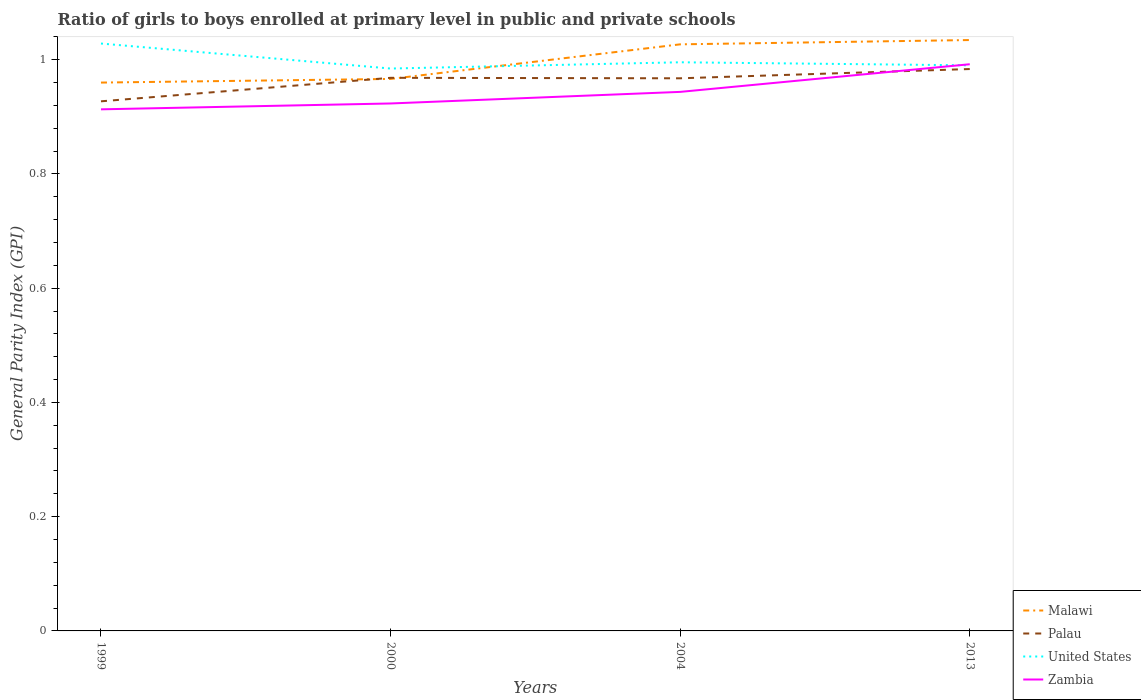Is the number of lines equal to the number of legend labels?
Your answer should be very brief. Yes. Across all years, what is the maximum general parity index in Malawi?
Offer a terse response. 0.96. What is the total general parity index in Zambia in the graph?
Make the answer very short. -0.03. What is the difference between the highest and the second highest general parity index in Palau?
Your answer should be compact. 0.06. Is the general parity index in United States strictly greater than the general parity index in Palau over the years?
Make the answer very short. No. How many lines are there?
Offer a terse response. 4. How many years are there in the graph?
Ensure brevity in your answer.  4. What is the difference between two consecutive major ticks on the Y-axis?
Keep it short and to the point. 0.2. Are the values on the major ticks of Y-axis written in scientific E-notation?
Ensure brevity in your answer.  No. Does the graph contain any zero values?
Provide a succinct answer. No. Does the graph contain grids?
Keep it short and to the point. No. What is the title of the graph?
Keep it short and to the point. Ratio of girls to boys enrolled at primary level in public and private schools. Does "United Arab Emirates" appear as one of the legend labels in the graph?
Your answer should be very brief. No. What is the label or title of the X-axis?
Offer a terse response. Years. What is the label or title of the Y-axis?
Your response must be concise. General Parity Index (GPI). What is the General Parity Index (GPI) of Malawi in 1999?
Offer a very short reply. 0.96. What is the General Parity Index (GPI) in Palau in 1999?
Keep it short and to the point. 0.93. What is the General Parity Index (GPI) of United States in 1999?
Make the answer very short. 1.03. What is the General Parity Index (GPI) of Zambia in 1999?
Offer a terse response. 0.91. What is the General Parity Index (GPI) in Malawi in 2000?
Ensure brevity in your answer.  0.97. What is the General Parity Index (GPI) in Palau in 2000?
Give a very brief answer. 0.97. What is the General Parity Index (GPI) in United States in 2000?
Your answer should be compact. 0.98. What is the General Parity Index (GPI) of Zambia in 2000?
Ensure brevity in your answer.  0.92. What is the General Parity Index (GPI) of Malawi in 2004?
Your answer should be compact. 1.03. What is the General Parity Index (GPI) of Palau in 2004?
Make the answer very short. 0.97. What is the General Parity Index (GPI) of United States in 2004?
Offer a terse response. 1. What is the General Parity Index (GPI) in Zambia in 2004?
Make the answer very short. 0.94. What is the General Parity Index (GPI) in Malawi in 2013?
Your answer should be compact. 1.03. What is the General Parity Index (GPI) in Palau in 2013?
Offer a terse response. 0.98. What is the General Parity Index (GPI) in United States in 2013?
Make the answer very short. 0.99. What is the General Parity Index (GPI) in Zambia in 2013?
Your response must be concise. 0.99. Across all years, what is the maximum General Parity Index (GPI) of Malawi?
Provide a succinct answer. 1.03. Across all years, what is the maximum General Parity Index (GPI) in Palau?
Give a very brief answer. 0.98. Across all years, what is the maximum General Parity Index (GPI) in United States?
Give a very brief answer. 1.03. Across all years, what is the maximum General Parity Index (GPI) of Zambia?
Make the answer very short. 0.99. Across all years, what is the minimum General Parity Index (GPI) of Malawi?
Your answer should be compact. 0.96. Across all years, what is the minimum General Parity Index (GPI) in Palau?
Provide a succinct answer. 0.93. Across all years, what is the minimum General Parity Index (GPI) of United States?
Your answer should be very brief. 0.98. Across all years, what is the minimum General Parity Index (GPI) of Zambia?
Give a very brief answer. 0.91. What is the total General Parity Index (GPI) of Malawi in the graph?
Your answer should be very brief. 3.99. What is the total General Parity Index (GPI) of Palau in the graph?
Your answer should be very brief. 3.85. What is the total General Parity Index (GPI) of United States in the graph?
Provide a succinct answer. 4. What is the total General Parity Index (GPI) of Zambia in the graph?
Ensure brevity in your answer.  3.77. What is the difference between the General Parity Index (GPI) of Malawi in 1999 and that in 2000?
Offer a very short reply. -0.01. What is the difference between the General Parity Index (GPI) of Palau in 1999 and that in 2000?
Make the answer very short. -0.04. What is the difference between the General Parity Index (GPI) of United States in 1999 and that in 2000?
Provide a short and direct response. 0.04. What is the difference between the General Parity Index (GPI) in Zambia in 1999 and that in 2000?
Provide a short and direct response. -0.01. What is the difference between the General Parity Index (GPI) in Malawi in 1999 and that in 2004?
Offer a very short reply. -0.07. What is the difference between the General Parity Index (GPI) of Palau in 1999 and that in 2004?
Offer a very short reply. -0.04. What is the difference between the General Parity Index (GPI) of United States in 1999 and that in 2004?
Provide a short and direct response. 0.03. What is the difference between the General Parity Index (GPI) in Zambia in 1999 and that in 2004?
Keep it short and to the point. -0.03. What is the difference between the General Parity Index (GPI) in Malawi in 1999 and that in 2013?
Keep it short and to the point. -0.07. What is the difference between the General Parity Index (GPI) of Palau in 1999 and that in 2013?
Provide a short and direct response. -0.06. What is the difference between the General Parity Index (GPI) in United States in 1999 and that in 2013?
Ensure brevity in your answer.  0.04. What is the difference between the General Parity Index (GPI) of Zambia in 1999 and that in 2013?
Offer a very short reply. -0.08. What is the difference between the General Parity Index (GPI) of Malawi in 2000 and that in 2004?
Your answer should be very brief. -0.06. What is the difference between the General Parity Index (GPI) of Palau in 2000 and that in 2004?
Provide a short and direct response. 0. What is the difference between the General Parity Index (GPI) of United States in 2000 and that in 2004?
Ensure brevity in your answer.  -0.01. What is the difference between the General Parity Index (GPI) of Zambia in 2000 and that in 2004?
Ensure brevity in your answer.  -0.02. What is the difference between the General Parity Index (GPI) of Malawi in 2000 and that in 2013?
Your response must be concise. -0.07. What is the difference between the General Parity Index (GPI) of Palau in 2000 and that in 2013?
Your answer should be compact. -0.02. What is the difference between the General Parity Index (GPI) in United States in 2000 and that in 2013?
Give a very brief answer. -0.01. What is the difference between the General Parity Index (GPI) in Zambia in 2000 and that in 2013?
Your answer should be very brief. -0.07. What is the difference between the General Parity Index (GPI) of Malawi in 2004 and that in 2013?
Make the answer very short. -0.01. What is the difference between the General Parity Index (GPI) in Palau in 2004 and that in 2013?
Your answer should be compact. -0.02. What is the difference between the General Parity Index (GPI) of United States in 2004 and that in 2013?
Offer a terse response. 0.01. What is the difference between the General Parity Index (GPI) of Zambia in 2004 and that in 2013?
Offer a very short reply. -0.05. What is the difference between the General Parity Index (GPI) in Malawi in 1999 and the General Parity Index (GPI) in Palau in 2000?
Provide a short and direct response. -0.01. What is the difference between the General Parity Index (GPI) of Malawi in 1999 and the General Parity Index (GPI) of United States in 2000?
Your response must be concise. -0.02. What is the difference between the General Parity Index (GPI) of Malawi in 1999 and the General Parity Index (GPI) of Zambia in 2000?
Provide a short and direct response. 0.04. What is the difference between the General Parity Index (GPI) in Palau in 1999 and the General Parity Index (GPI) in United States in 2000?
Ensure brevity in your answer.  -0.06. What is the difference between the General Parity Index (GPI) of Palau in 1999 and the General Parity Index (GPI) of Zambia in 2000?
Keep it short and to the point. 0. What is the difference between the General Parity Index (GPI) of United States in 1999 and the General Parity Index (GPI) of Zambia in 2000?
Your response must be concise. 0.1. What is the difference between the General Parity Index (GPI) of Malawi in 1999 and the General Parity Index (GPI) of Palau in 2004?
Your response must be concise. -0.01. What is the difference between the General Parity Index (GPI) of Malawi in 1999 and the General Parity Index (GPI) of United States in 2004?
Your response must be concise. -0.04. What is the difference between the General Parity Index (GPI) of Malawi in 1999 and the General Parity Index (GPI) of Zambia in 2004?
Provide a short and direct response. 0.02. What is the difference between the General Parity Index (GPI) of Palau in 1999 and the General Parity Index (GPI) of United States in 2004?
Your response must be concise. -0.07. What is the difference between the General Parity Index (GPI) in Palau in 1999 and the General Parity Index (GPI) in Zambia in 2004?
Your response must be concise. -0.02. What is the difference between the General Parity Index (GPI) of United States in 1999 and the General Parity Index (GPI) of Zambia in 2004?
Give a very brief answer. 0.08. What is the difference between the General Parity Index (GPI) in Malawi in 1999 and the General Parity Index (GPI) in Palau in 2013?
Ensure brevity in your answer.  -0.02. What is the difference between the General Parity Index (GPI) in Malawi in 1999 and the General Parity Index (GPI) in United States in 2013?
Offer a very short reply. -0.03. What is the difference between the General Parity Index (GPI) in Malawi in 1999 and the General Parity Index (GPI) in Zambia in 2013?
Your response must be concise. -0.03. What is the difference between the General Parity Index (GPI) in Palau in 1999 and the General Parity Index (GPI) in United States in 2013?
Make the answer very short. -0.06. What is the difference between the General Parity Index (GPI) of Palau in 1999 and the General Parity Index (GPI) of Zambia in 2013?
Keep it short and to the point. -0.06. What is the difference between the General Parity Index (GPI) in United States in 1999 and the General Parity Index (GPI) in Zambia in 2013?
Provide a short and direct response. 0.04. What is the difference between the General Parity Index (GPI) in Malawi in 2000 and the General Parity Index (GPI) in Palau in 2004?
Give a very brief answer. -0. What is the difference between the General Parity Index (GPI) of Malawi in 2000 and the General Parity Index (GPI) of United States in 2004?
Your answer should be compact. -0.03. What is the difference between the General Parity Index (GPI) of Malawi in 2000 and the General Parity Index (GPI) of Zambia in 2004?
Ensure brevity in your answer.  0.02. What is the difference between the General Parity Index (GPI) of Palau in 2000 and the General Parity Index (GPI) of United States in 2004?
Your answer should be very brief. -0.03. What is the difference between the General Parity Index (GPI) of Palau in 2000 and the General Parity Index (GPI) of Zambia in 2004?
Ensure brevity in your answer.  0.02. What is the difference between the General Parity Index (GPI) of United States in 2000 and the General Parity Index (GPI) of Zambia in 2004?
Make the answer very short. 0.04. What is the difference between the General Parity Index (GPI) of Malawi in 2000 and the General Parity Index (GPI) of Palau in 2013?
Offer a very short reply. -0.02. What is the difference between the General Parity Index (GPI) of Malawi in 2000 and the General Parity Index (GPI) of United States in 2013?
Offer a very short reply. -0.02. What is the difference between the General Parity Index (GPI) in Malawi in 2000 and the General Parity Index (GPI) in Zambia in 2013?
Your answer should be very brief. -0.03. What is the difference between the General Parity Index (GPI) in Palau in 2000 and the General Parity Index (GPI) in United States in 2013?
Give a very brief answer. -0.02. What is the difference between the General Parity Index (GPI) in Palau in 2000 and the General Parity Index (GPI) in Zambia in 2013?
Keep it short and to the point. -0.02. What is the difference between the General Parity Index (GPI) in United States in 2000 and the General Parity Index (GPI) in Zambia in 2013?
Keep it short and to the point. -0.01. What is the difference between the General Parity Index (GPI) in Malawi in 2004 and the General Parity Index (GPI) in Palau in 2013?
Keep it short and to the point. 0.04. What is the difference between the General Parity Index (GPI) of Malawi in 2004 and the General Parity Index (GPI) of United States in 2013?
Give a very brief answer. 0.04. What is the difference between the General Parity Index (GPI) in Malawi in 2004 and the General Parity Index (GPI) in Zambia in 2013?
Your response must be concise. 0.03. What is the difference between the General Parity Index (GPI) in Palau in 2004 and the General Parity Index (GPI) in United States in 2013?
Your answer should be compact. -0.02. What is the difference between the General Parity Index (GPI) in Palau in 2004 and the General Parity Index (GPI) in Zambia in 2013?
Your response must be concise. -0.02. What is the difference between the General Parity Index (GPI) of United States in 2004 and the General Parity Index (GPI) of Zambia in 2013?
Provide a short and direct response. 0. What is the average General Parity Index (GPI) of Palau per year?
Offer a terse response. 0.96. What is the average General Parity Index (GPI) in United States per year?
Offer a very short reply. 1. What is the average General Parity Index (GPI) in Zambia per year?
Your answer should be very brief. 0.94. In the year 1999, what is the difference between the General Parity Index (GPI) in Malawi and General Parity Index (GPI) in Palau?
Make the answer very short. 0.03. In the year 1999, what is the difference between the General Parity Index (GPI) in Malawi and General Parity Index (GPI) in United States?
Offer a terse response. -0.07. In the year 1999, what is the difference between the General Parity Index (GPI) of Malawi and General Parity Index (GPI) of Zambia?
Give a very brief answer. 0.05. In the year 1999, what is the difference between the General Parity Index (GPI) in Palau and General Parity Index (GPI) in United States?
Offer a terse response. -0.1. In the year 1999, what is the difference between the General Parity Index (GPI) of Palau and General Parity Index (GPI) of Zambia?
Your answer should be compact. 0.01. In the year 1999, what is the difference between the General Parity Index (GPI) of United States and General Parity Index (GPI) of Zambia?
Offer a terse response. 0.12. In the year 2000, what is the difference between the General Parity Index (GPI) in Malawi and General Parity Index (GPI) in Palau?
Give a very brief answer. -0. In the year 2000, what is the difference between the General Parity Index (GPI) of Malawi and General Parity Index (GPI) of United States?
Ensure brevity in your answer.  -0.02. In the year 2000, what is the difference between the General Parity Index (GPI) of Malawi and General Parity Index (GPI) of Zambia?
Provide a succinct answer. 0.04. In the year 2000, what is the difference between the General Parity Index (GPI) in Palau and General Parity Index (GPI) in United States?
Offer a terse response. -0.02. In the year 2000, what is the difference between the General Parity Index (GPI) of Palau and General Parity Index (GPI) of Zambia?
Your answer should be compact. 0.04. In the year 2000, what is the difference between the General Parity Index (GPI) in United States and General Parity Index (GPI) in Zambia?
Keep it short and to the point. 0.06. In the year 2004, what is the difference between the General Parity Index (GPI) of Malawi and General Parity Index (GPI) of Palau?
Your response must be concise. 0.06. In the year 2004, what is the difference between the General Parity Index (GPI) in Malawi and General Parity Index (GPI) in United States?
Provide a short and direct response. 0.03. In the year 2004, what is the difference between the General Parity Index (GPI) of Malawi and General Parity Index (GPI) of Zambia?
Keep it short and to the point. 0.08. In the year 2004, what is the difference between the General Parity Index (GPI) of Palau and General Parity Index (GPI) of United States?
Your response must be concise. -0.03. In the year 2004, what is the difference between the General Parity Index (GPI) of Palau and General Parity Index (GPI) of Zambia?
Ensure brevity in your answer.  0.02. In the year 2004, what is the difference between the General Parity Index (GPI) in United States and General Parity Index (GPI) in Zambia?
Ensure brevity in your answer.  0.05. In the year 2013, what is the difference between the General Parity Index (GPI) in Malawi and General Parity Index (GPI) in Palau?
Give a very brief answer. 0.05. In the year 2013, what is the difference between the General Parity Index (GPI) in Malawi and General Parity Index (GPI) in United States?
Offer a terse response. 0.04. In the year 2013, what is the difference between the General Parity Index (GPI) in Malawi and General Parity Index (GPI) in Zambia?
Offer a terse response. 0.04. In the year 2013, what is the difference between the General Parity Index (GPI) in Palau and General Parity Index (GPI) in United States?
Your answer should be very brief. -0.01. In the year 2013, what is the difference between the General Parity Index (GPI) of Palau and General Parity Index (GPI) of Zambia?
Your response must be concise. -0.01. In the year 2013, what is the difference between the General Parity Index (GPI) of United States and General Parity Index (GPI) of Zambia?
Your answer should be very brief. -0. What is the ratio of the General Parity Index (GPI) in Palau in 1999 to that in 2000?
Ensure brevity in your answer.  0.96. What is the ratio of the General Parity Index (GPI) of United States in 1999 to that in 2000?
Give a very brief answer. 1.04. What is the ratio of the General Parity Index (GPI) of Zambia in 1999 to that in 2000?
Make the answer very short. 0.99. What is the ratio of the General Parity Index (GPI) of Malawi in 1999 to that in 2004?
Your answer should be very brief. 0.93. What is the ratio of the General Parity Index (GPI) of Palau in 1999 to that in 2004?
Your answer should be very brief. 0.96. What is the ratio of the General Parity Index (GPI) of United States in 1999 to that in 2004?
Offer a very short reply. 1.03. What is the ratio of the General Parity Index (GPI) of Zambia in 1999 to that in 2004?
Your response must be concise. 0.97. What is the ratio of the General Parity Index (GPI) in Malawi in 1999 to that in 2013?
Make the answer very short. 0.93. What is the ratio of the General Parity Index (GPI) of Palau in 1999 to that in 2013?
Give a very brief answer. 0.94. What is the ratio of the General Parity Index (GPI) of Zambia in 1999 to that in 2013?
Provide a succinct answer. 0.92. What is the ratio of the General Parity Index (GPI) in Malawi in 2000 to that in 2004?
Keep it short and to the point. 0.94. What is the ratio of the General Parity Index (GPI) of Palau in 2000 to that in 2004?
Keep it short and to the point. 1. What is the ratio of the General Parity Index (GPI) in United States in 2000 to that in 2004?
Offer a very short reply. 0.99. What is the ratio of the General Parity Index (GPI) in Zambia in 2000 to that in 2004?
Your answer should be compact. 0.98. What is the ratio of the General Parity Index (GPI) of Malawi in 2000 to that in 2013?
Offer a very short reply. 0.93. What is the ratio of the General Parity Index (GPI) in Palau in 2000 to that in 2013?
Your answer should be very brief. 0.98. What is the ratio of the General Parity Index (GPI) of United States in 2000 to that in 2013?
Give a very brief answer. 0.99. What is the ratio of the General Parity Index (GPI) in Zambia in 2000 to that in 2013?
Provide a succinct answer. 0.93. What is the ratio of the General Parity Index (GPI) of Malawi in 2004 to that in 2013?
Make the answer very short. 0.99. What is the ratio of the General Parity Index (GPI) of Palau in 2004 to that in 2013?
Ensure brevity in your answer.  0.98. What is the ratio of the General Parity Index (GPI) in United States in 2004 to that in 2013?
Give a very brief answer. 1.01. What is the ratio of the General Parity Index (GPI) of Zambia in 2004 to that in 2013?
Offer a very short reply. 0.95. What is the difference between the highest and the second highest General Parity Index (GPI) in Malawi?
Ensure brevity in your answer.  0.01. What is the difference between the highest and the second highest General Parity Index (GPI) of Palau?
Give a very brief answer. 0.02. What is the difference between the highest and the second highest General Parity Index (GPI) in United States?
Keep it short and to the point. 0.03. What is the difference between the highest and the second highest General Parity Index (GPI) of Zambia?
Give a very brief answer. 0.05. What is the difference between the highest and the lowest General Parity Index (GPI) in Malawi?
Provide a short and direct response. 0.07. What is the difference between the highest and the lowest General Parity Index (GPI) of Palau?
Offer a terse response. 0.06. What is the difference between the highest and the lowest General Parity Index (GPI) in United States?
Your response must be concise. 0.04. What is the difference between the highest and the lowest General Parity Index (GPI) in Zambia?
Provide a succinct answer. 0.08. 